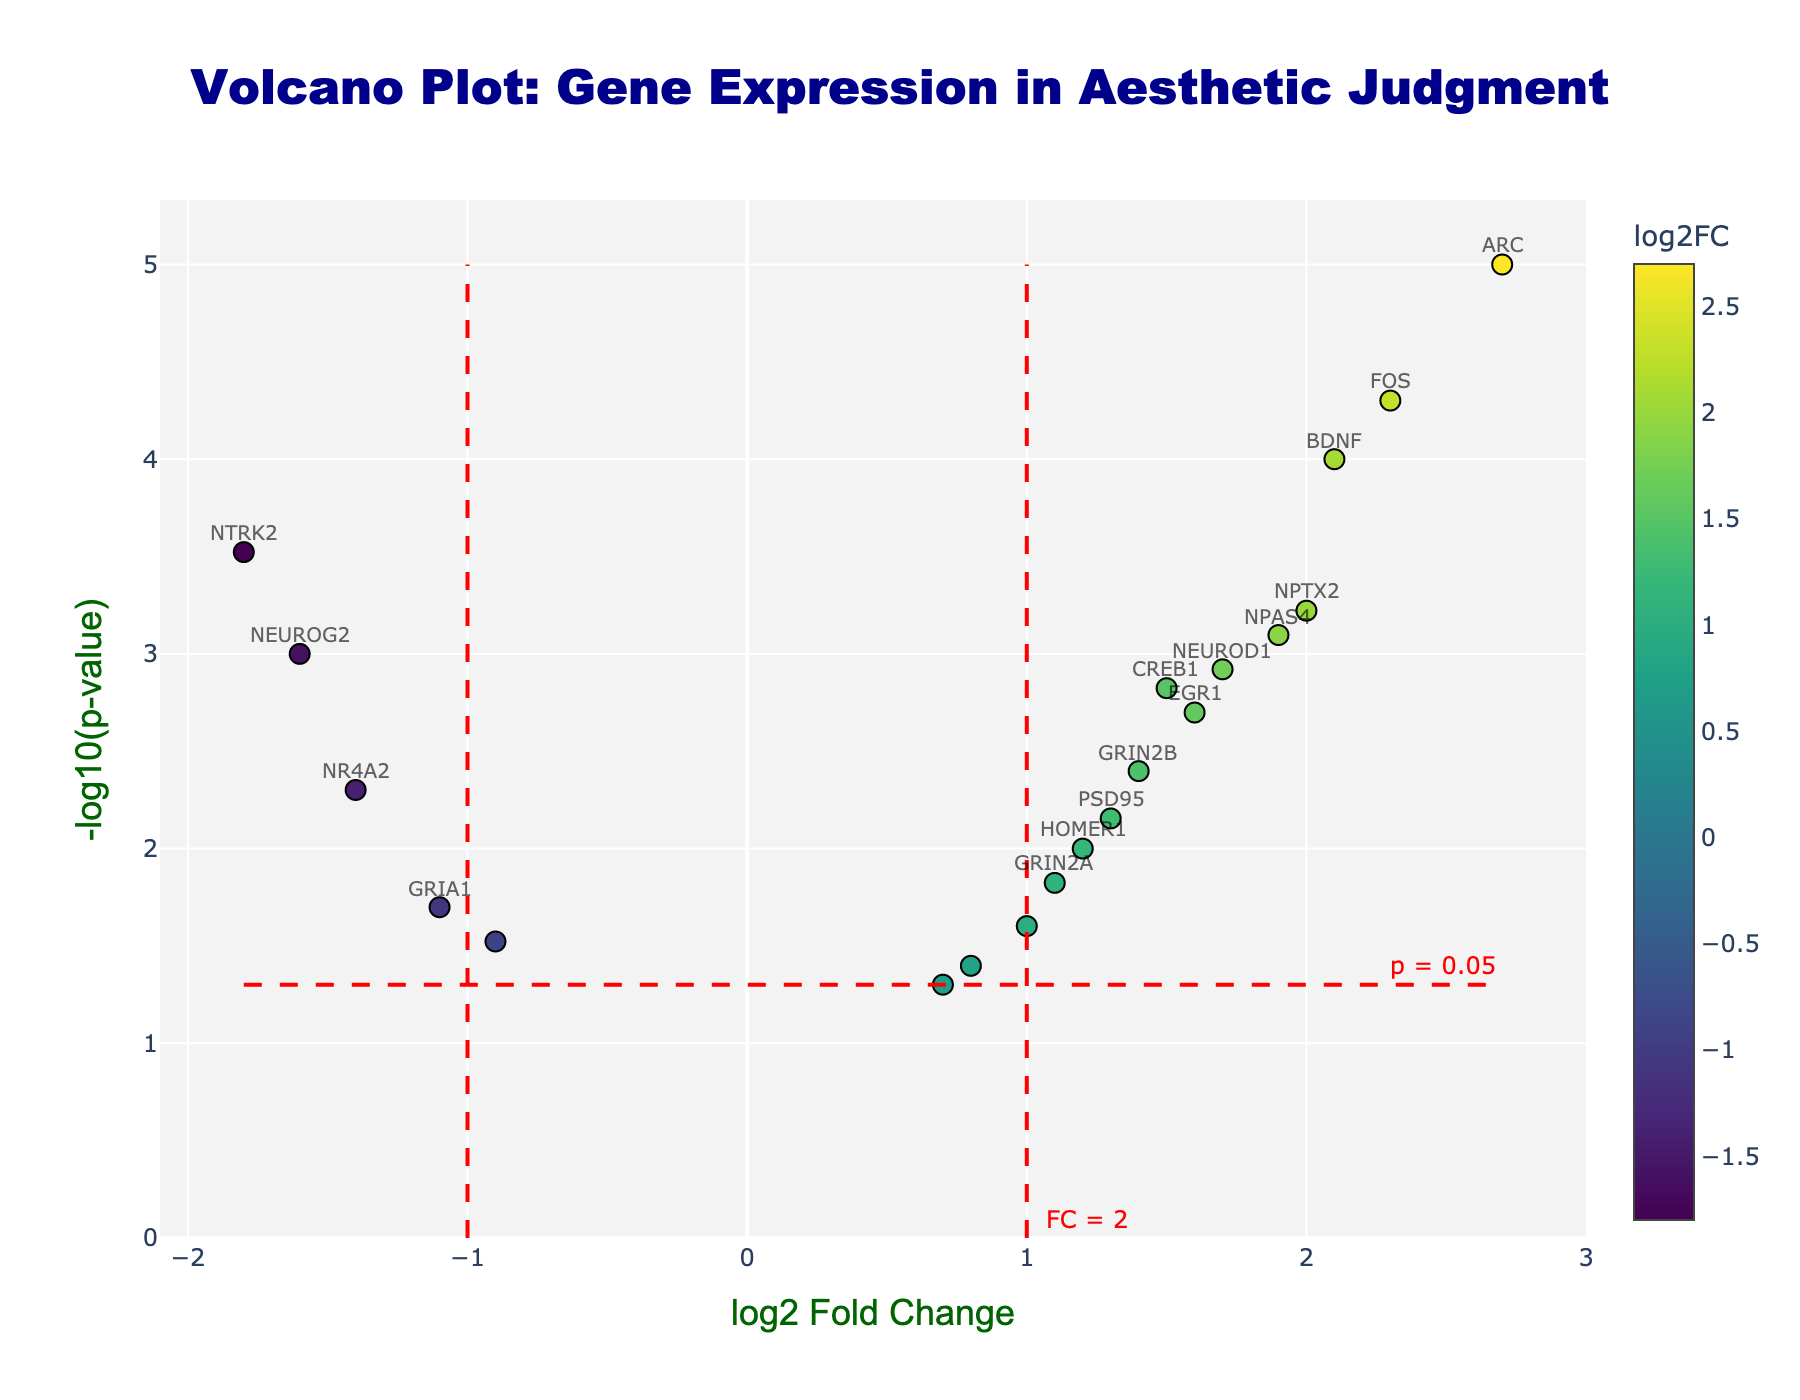What is the title of the plot? The title of the plot is written at the top of the figure in large, bold dark blue text.
Answer: Volcano Plot: Gene Expression in Aesthetic Judgment What does the x-axis represent? The x-axis label is specified below the axis line and states 'log2 Fold Change'.
Answer: log2 Fold Change How many genes have a significant change in expression (log2FC > 1 and p < 0.05)? To find this, look for data points labeled with gene names, as these indicate significant changes. Count the genes: BDNF, FOS, NPAS4, ARC, NEUROD1, NPTX2.
Answer: 6 Which gene shows the highest -log10(p-value)? Identify the highest point on the y-axis and check its label. The highest point is ARC.
Answer: ARC What is the color scale used for the markers? The color scale is explicitly mentioned in the figure's colorbar, which indicates the 'Viridis' color scale ranging from purple to yellow variants.
Answer: Viridis What is the log2 Fold Change of the NTRK2 gene? Locate the NTRK2 gene label on the plot and note its position on the x-axis, which shows a negative log2 Fold Change close to -1.8.
Answer: -1.8 Compare the p-value of BDNF and CREB1. Which one is more significant? Check the y-axis (p-value in log10 format) of both genes. BDNF has a higher -log10(p-value) than CREB1, indicating a more significant p-value.
Answer: BDNF Which gene has the lowest log2 Fold Change? Find the point farthest to the left on the x-axis. The leftmost point represents NTRK2 with -1.8 log2 Fold Change.
Answer: NTRK2 Are there any genes with a log2 Fold Change of around 0.7? Scan along the x-value of 0.7 and look for nearby markers. The gene CALM1 has a log2 Fold Change of around 0.7.
Answer: CALM1 How many genes have a p-value equal to or less than 0.01? Determine the number of data points above the -log10(p-value) threshold of 2 (since -log10(0.01) = 2). The genes are BDNF, NTRK2, FOS, NPAS4, NPTX2, NEUROD1.
Answer: 6 